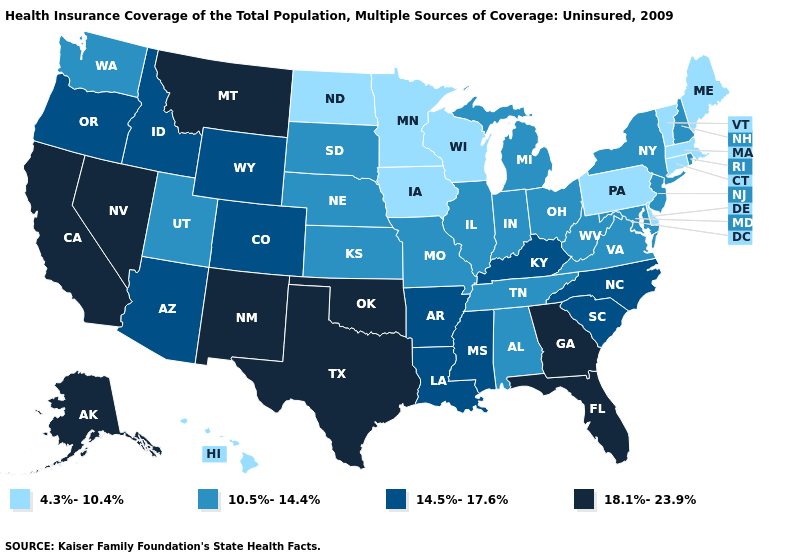What is the highest value in states that border Arizona?
Concise answer only. 18.1%-23.9%. What is the value of Minnesota?
Give a very brief answer. 4.3%-10.4%. Which states have the highest value in the USA?
Be succinct. Alaska, California, Florida, Georgia, Montana, Nevada, New Mexico, Oklahoma, Texas. What is the value of South Dakota?
Answer briefly. 10.5%-14.4%. What is the value of Pennsylvania?
Concise answer only. 4.3%-10.4%. Is the legend a continuous bar?
Short answer required. No. Among the states that border Ohio , does Pennsylvania have the lowest value?
Concise answer only. Yes. What is the value of Alaska?
Give a very brief answer. 18.1%-23.9%. Name the states that have a value in the range 10.5%-14.4%?
Write a very short answer. Alabama, Illinois, Indiana, Kansas, Maryland, Michigan, Missouri, Nebraska, New Hampshire, New Jersey, New York, Ohio, Rhode Island, South Dakota, Tennessee, Utah, Virginia, Washington, West Virginia. Among the states that border Idaho , which have the highest value?
Concise answer only. Montana, Nevada. What is the highest value in the USA?
Be succinct. 18.1%-23.9%. What is the value of New Jersey?
Short answer required. 10.5%-14.4%. What is the lowest value in the USA?
Give a very brief answer. 4.3%-10.4%. What is the value of Idaho?
Answer briefly. 14.5%-17.6%. What is the highest value in states that border Wyoming?
Give a very brief answer. 18.1%-23.9%. 